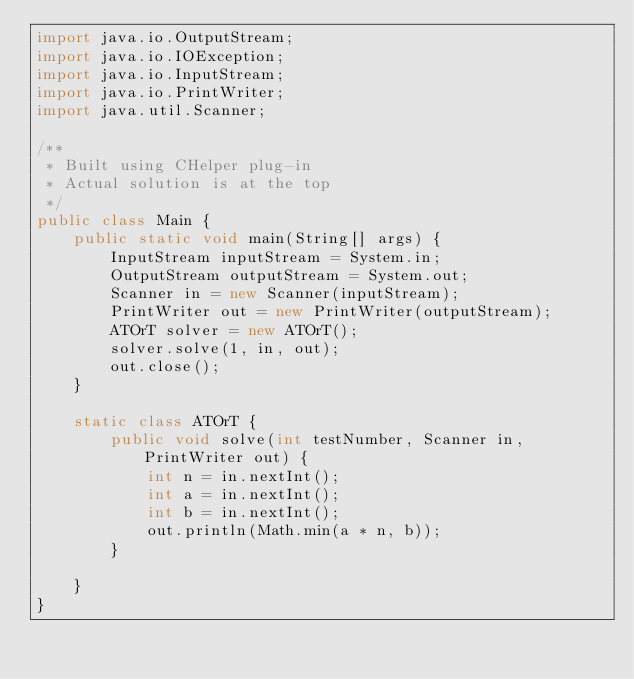<code> <loc_0><loc_0><loc_500><loc_500><_Java_>import java.io.OutputStream;
import java.io.IOException;
import java.io.InputStream;
import java.io.PrintWriter;
import java.util.Scanner;

/**
 * Built using CHelper plug-in
 * Actual solution is at the top
 */
public class Main {
    public static void main(String[] args) {
        InputStream inputStream = System.in;
        OutputStream outputStream = System.out;
        Scanner in = new Scanner(inputStream);
        PrintWriter out = new PrintWriter(outputStream);
        ATOrT solver = new ATOrT();
        solver.solve(1, in, out);
        out.close();
    }

    static class ATOrT {
        public void solve(int testNumber, Scanner in, PrintWriter out) {
            int n = in.nextInt();
            int a = in.nextInt();
            int b = in.nextInt();
            out.println(Math.min(a * n, b));
        }

    }
}

</code> 